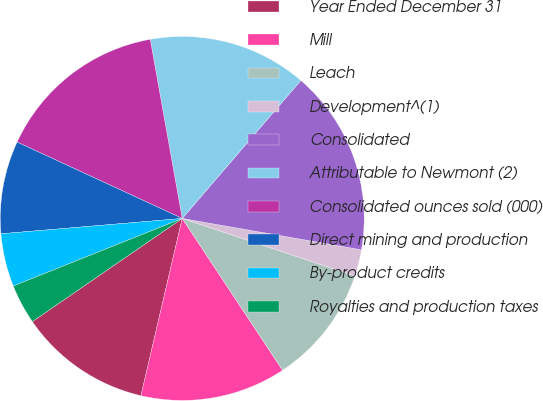Convert chart. <chart><loc_0><loc_0><loc_500><loc_500><pie_chart><fcel>Year Ended December 31<fcel>Mill<fcel>Leach<fcel>Development^(1)<fcel>Consolidated<fcel>Attributable to Newmont (2)<fcel>Consolidated ounces sold (000)<fcel>Direct mining and production<fcel>By-product credits<fcel>Royalties and production taxes<nl><fcel>11.76%<fcel>12.94%<fcel>10.59%<fcel>2.36%<fcel>16.46%<fcel>14.11%<fcel>15.29%<fcel>8.24%<fcel>4.71%<fcel>3.54%<nl></chart> 